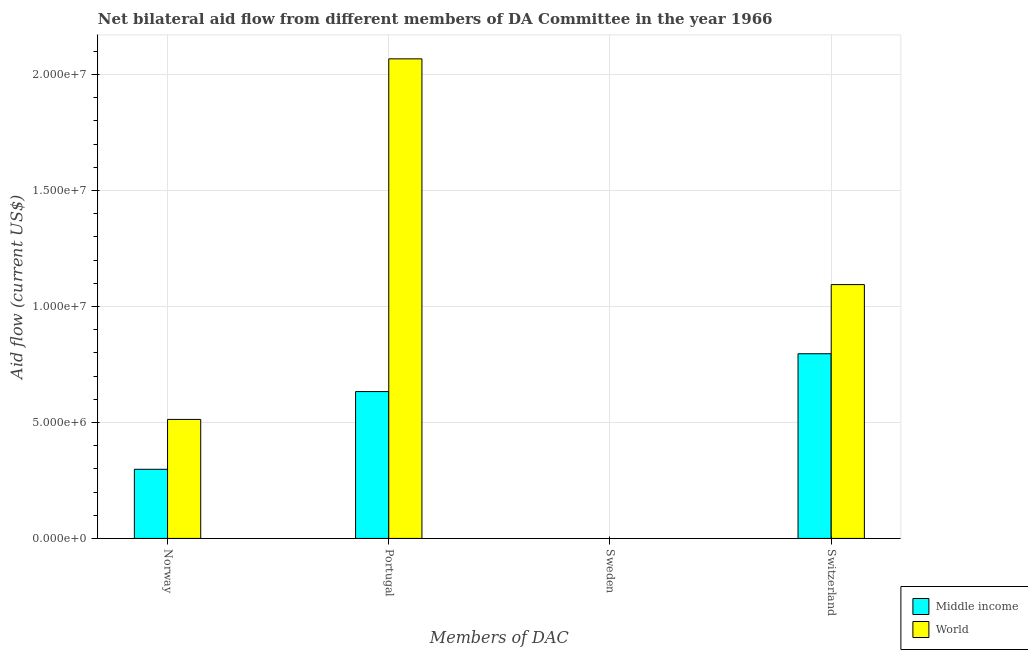Are the number of bars per tick equal to the number of legend labels?
Offer a very short reply. No. How many bars are there on the 2nd tick from the left?
Provide a short and direct response. 2. Across all countries, what is the maximum amount of aid given by portugal?
Give a very brief answer. 2.07e+07. Across all countries, what is the minimum amount of aid given by switzerland?
Give a very brief answer. 7.96e+06. What is the total amount of aid given by norway in the graph?
Your answer should be very brief. 8.11e+06. What is the difference between the amount of aid given by norway in World and that in Middle income?
Your answer should be compact. 2.15e+06. What is the difference between the amount of aid given by portugal in Middle income and the amount of aid given by norway in World?
Your answer should be very brief. 1.20e+06. What is the average amount of aid given by portugal per country?
Your answer should be compact. 1.35e+07. What is the difference between the amount of aid given by norway and amount of aid given by switzerland in World?
Your response must be concise. -5.81e+06. What is the ratio of the amount of aid given by portugal in World to that in Middle income?
Give a very brief answer. 3.27. What is the difference between the highest and the second highest amount of aid given by switzerland?
Give a very brief answer. 2.98e+06. What is the difference between the highest and the lowest amount of aid given by switzerland?
Your answer should be compact. 2.98e+06. Is it the case that in every country, the sum of the amount of aid given by sweden and amount of aid given by switzerland is greater than the sum of amount of aid given by norway and amount of aid given by portugal?
Offer a terse response. No. How many bars are there?
Provide a succinct answer. 8. What is the difference between two consecutive major ticks on the Y-axis?
Your answer should be compact. 5.00e+06. Are the values on the major ticks of Y-axis written in scientific E-notation?
Give a very brief answer. Yes. Does the graph contain grids?
Keep it short and to the point. Yes. What is the title of the graph?
Give a very brief answer. Net bilateral aid flow from different members of DA Committee in the year 1966. Does "New Caledonia" appear as one of the legend labels in the graph?
Offer a very short reply. No. What is the label or title of the X-axis?
Provide a succinct answer. Members of DAC. What is the Aid flow (current US$) of Middle income in Norway?
Give a very brief answer. 2.98e+06. What is the Aid flow (current US$) of World in Norway?
Offer a terse response. 5.13e+06. What is the Aid flow (current US$) of Middle income in Portugal?
Offer a very short reply. 6.33e+06. What is the Aid flow (current US$) of World in Portugal?
Provide a short and direct response. 2.07e+07. What is the Aid flow (current US$) in Middle income in Sweden?
Offer a terse response. Nan. What is the Aid flow (current US$) of World in Sweden?
Your response must be concise. Nan. What is the Aid flow (current US$) in Middle income in Switzerland?
Ensure brevity in your answer.  7.96e+06. What is the Aid flow (current US$) of World in Switzerland?
Give a very brief answer. 1.09e+07. Across all Members of DAC, what is the maximum Aid flow (current US$) of Middle income?
Give a very brief answer. 7.96e+06. Across all Members of DAC, what is the maximum Aid flow (current US$) of World?
Your response must be concise. 2.07e+07. Across all Members of DAC, what is the minimum Aid flow (current US$) of Middle income?
Provide a succinct answer. 2.98e+06. Across all Members of DAC, what is the minimum Aid flow (current US$) of World?
Your answer should be very brief. 5.13e+06. What is the total Aid flow (current US$) of Middle income in the graph?
Make the answer very short. 1.73e+07. What is the total Aid flow (current US$) of World in the graph?
Your answer should be compact. 3.67e+07. What is the difference between the Aid flow (current US$) in Middle income in Norway and that in Portugal?
Offer a very short reply. -3.35e+06. What is the difference between the Aid flow (current US$) of World in Norway and that in Portugal?
Your response must be concise. -1.55e+07. What is the difference between the Aid flow (current US$) of Middle income in Norway and that in Sweden?
Your answer should be very brief. Nan. What is the difference between the Aid flow (current US$) of World in Norway and that in Sweden?
Provide a short and direct response. Nan. What is the difference between the Aid flow (current US$) of Middle income in Norway and that in Switzerland?
Your answer should be compact. -4.98e+06. What is the difference between the Aid flow (current US$) in World in Norway and that in Switzerland?
Give a very brief answer. -5.81e+06. What is the difference between the Aid flow (current US$) of Middle income in Portugal and that in Sweden?
Your answer should be very brief. Nan. What is the difference between the Aid flow (current US$) of World in Portugal and that in Sweden?
Your answer should be very brief. Nan. What is the difference between the Aid flow (current US$) of Middle income in Portugal and that in Switzerland?
Offer a very short reply. -1.63e+06. What is the difference between the Aid flow (current US$) in World in Portugal and that in Switzerland?
Ensure brevity in your answer.  9.73e+06. What is the difference between the Aid flow (current US$) of Middle income in Sweden and that in Switzerland?
Provide a short and direct response. Nan. What is the difference between the Aid flow (current US$) of World in Sweden and that in Switzerland?
Your answer should be very brief. Nan. What is the difference between the Aid flow (current US$) of Middle income in Norway and the Aid flow (current US$) of World in Portugal?
Your answer should be compact. -1.77e+07. What is the difference between the Aid flow (current US$) in Middle income in Norway and the Aid flow (current US$) in World in Sweden?
Give a very brief answer. Nan. What is the difference between the Aid flow (current US$) in Middle income in Norway and the Aid flow (current US$) in World in Switzerland?
Your answer should be compact. -7.96e+06. What is the difference between the Aid flow (current US$) in Middle income in Portugal and the Aid flow (current US$) in World in Sweden?
Provide a succinct answer. Nan. What is the difference between the Aid flow (current US$) of Middle income in Portugal and the Aid flow (current US$) of World in Switzerland?
Offer a very short reply. -4.61e+06. What is the difference between the Aid flow (current US$) of Middle income in Sweden and the Aid flow (current US$) of World in Switzerland?
Your response must be concise. Nan. What is the average Aid flow (current US$) in Middle income per Members of DAC?
Provide a succinct answer. 4.32e+06. What is the average Aid flow (current US$) of World per Members of DAC?
Keep it short and to the point. 9.18e+06. What is the difference between the Aid flow (current US$) of Middle income and Aid flow (current US$) of World in Norway?
Provide a short and direct response. -2.15e+06. What is the difference between the Aid flow (current US$) in Middle income and Aid flow (current US$) in World in Portugal?
Provide a short and direct response. -1.43e+07. What is the difference between the Aid flow (current US$) in Middle income and Aid flow (current US$) in World in Sweden?
Your answer should be very brief. Nan. What is the difference between the Aid flow (current US$) in Middle income and Aid flow (current US$) in World in Switzerland?
Your response must be concise. -2.98e+06. What is the ratio of the Aid flow (current US$) in Middle income in Norway to that in Portugal?
Your answer should be very brief. 0.47. What is the ratio of the Aid flow (current US$) in World in Norway to that in Portugal?
Make the answer very short. 0.25. What is the ratio of the Aid flow (current US$) in Middle income in Norway to that in Sweden?
Make the answer very short. Nan. What is the ratio of the Aid flow (current US$) of World in Norway to that in Sweden?
Your response must be concise. Nan. What is the ratio of the Aid flow (current US$) of Middle income in Norway to that in Switzerland?
Give a very brief answer. 0.37. What is the ratio of the Aid flow (current US$) of World in Norway to that in Switzerland?
Your answer should be very brief. 0.47. What is the ratio of the Aid flow (current US$) of Middle income in Portugal to that in Sweden?
Ensure brevity in your answer.  Nan. What is the ratio of the Aid flow (current US$) in World in Portugal to that in Sweden?
Keep it short and to the point. Nan. What is the ratio of the Aid flow (current US$) of Middle income in Portugal to that in Switzerland?
Offer a very short reply. 0.8. What is the ratio of the Aid flow (current US$) of World in Portugal to that in Switzerland?
Make the answer very short. 1.89. What is the ratio of the Aid flow (current US$) in Middle income in Sweden to that in Switzerland?
Keep it short and to the point. Nan. What is the ratio of the Aid flow (current US$) of World in Sweden to that in Switzerland?
Your response must be concise. Nan. What is the difference between the highest and the second highest Aid flow (current US$) of Middle income?
Your answer should be compact. 1.63e+06. What is the difference between the highest and the second highest Aid flow (current US$) of World?
Keep it short and to the point. 9.73e+06. What is the difference between the highest and the lowest Aid flow (current US$) in Middle income?
Keep it short and to the point. 4.98e+06. What is the difference between the highest and the lowest Aid flow (current US$) in World?
Your response must be concise. 1.55e+07. 